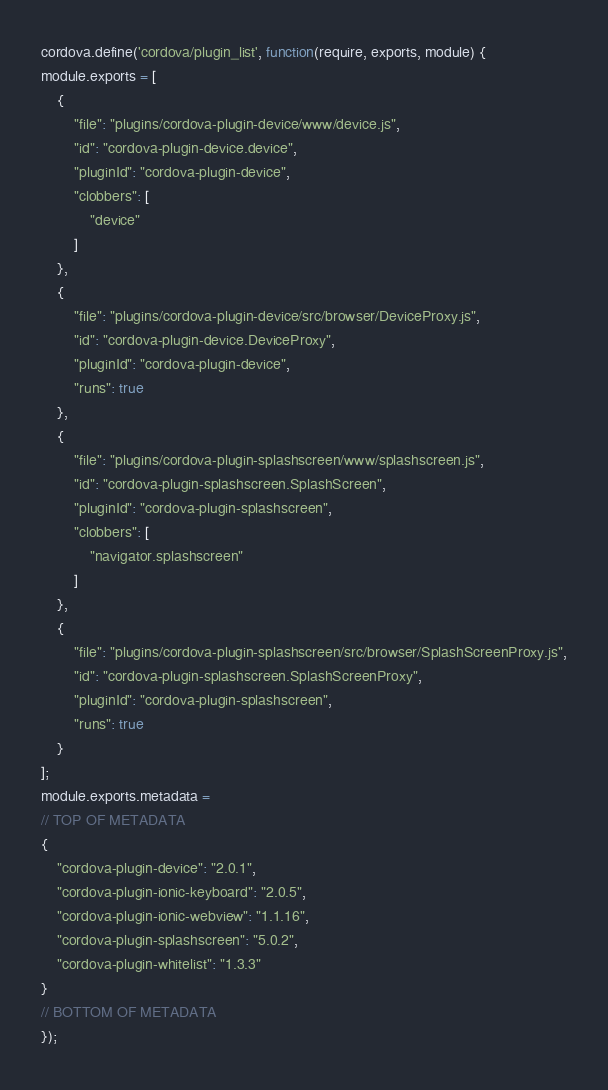<code> <loc_0><loc_0><loc_500><loc_500><_JavaScript_>cordova.define('cordova/plugin_list', function(require, exports, module) {
module.exports = [
    {
        "file": "plugins/cordova-plugin-device/www/device.js",
        "id": "cordova-plugin-device.device",
        "pluginId": "cordova-plugin-device",
        "clobbers": [
            "device"
        ]
    },
    {
        "file": "plugins/cordova-plugin-device/src/browser/DeviceProxy.js",
        "id": "cordova-plugin-device.DeviceProxy",
        "pluginId": "cordova-plugin-device",
        "runs": true
    },
    {
        "file": "plugins/cordova-plugin-splashscreen/www/splashscreen.js",
        "id": "cordova-plugin-splashscreen.SplashScreen",
        "pluginId": "cordova-plugin-splashscreen",
        "clobbers": [
            "navigator.splashscreen"
        ]
    },
    {
        "file": "plugins/cordova-plugin-splashscreen/src/browser/SplashScreenProxy.js",
        "id": "cordova-plugin-splashscreen.SplashScreenProxy",
        "pluginId": "cordova-plugin-splashscreen",
        "runs": true
    }
];
module.exports.metadata = 
// TOP OF METADATA
{
    "cordova-plugin-device": "2.0.1",
    "cordova-plugin-ionic-keyboard": "2.0.5",
    "cordova-plugin-ionic-webview": "1.1.16",
    "cordova-plugin-splashscreen": "5.0.2",
    "cordova-plugin-whitelist": "1.3.3"
}
// BOTTOM OF METADATA
});</code> 